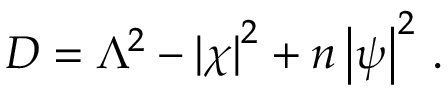Convert formula to latex. <formula><loc_0><loc_0><loc_500><loc_500>D = \Lambda ^ { 2 } - \left | \chi \right | ^ { 2 } + n \left | \psi \right | ^ { 2 } \, .</formula> 